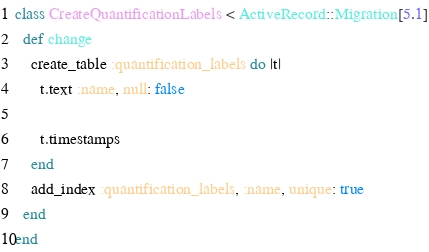<code> <loc_0><loc_0><loc_500><loc_500><_Ruby_>class CreateQuantificationLabels < ActiveRecord::Migration[5.1]
  def change
    create_table :quantification_labels do |t|
      t.text :name, null: false

      t.timestamps
    end
    add_index :quantification_labels, :name, unique: true
  end
end
</code> 